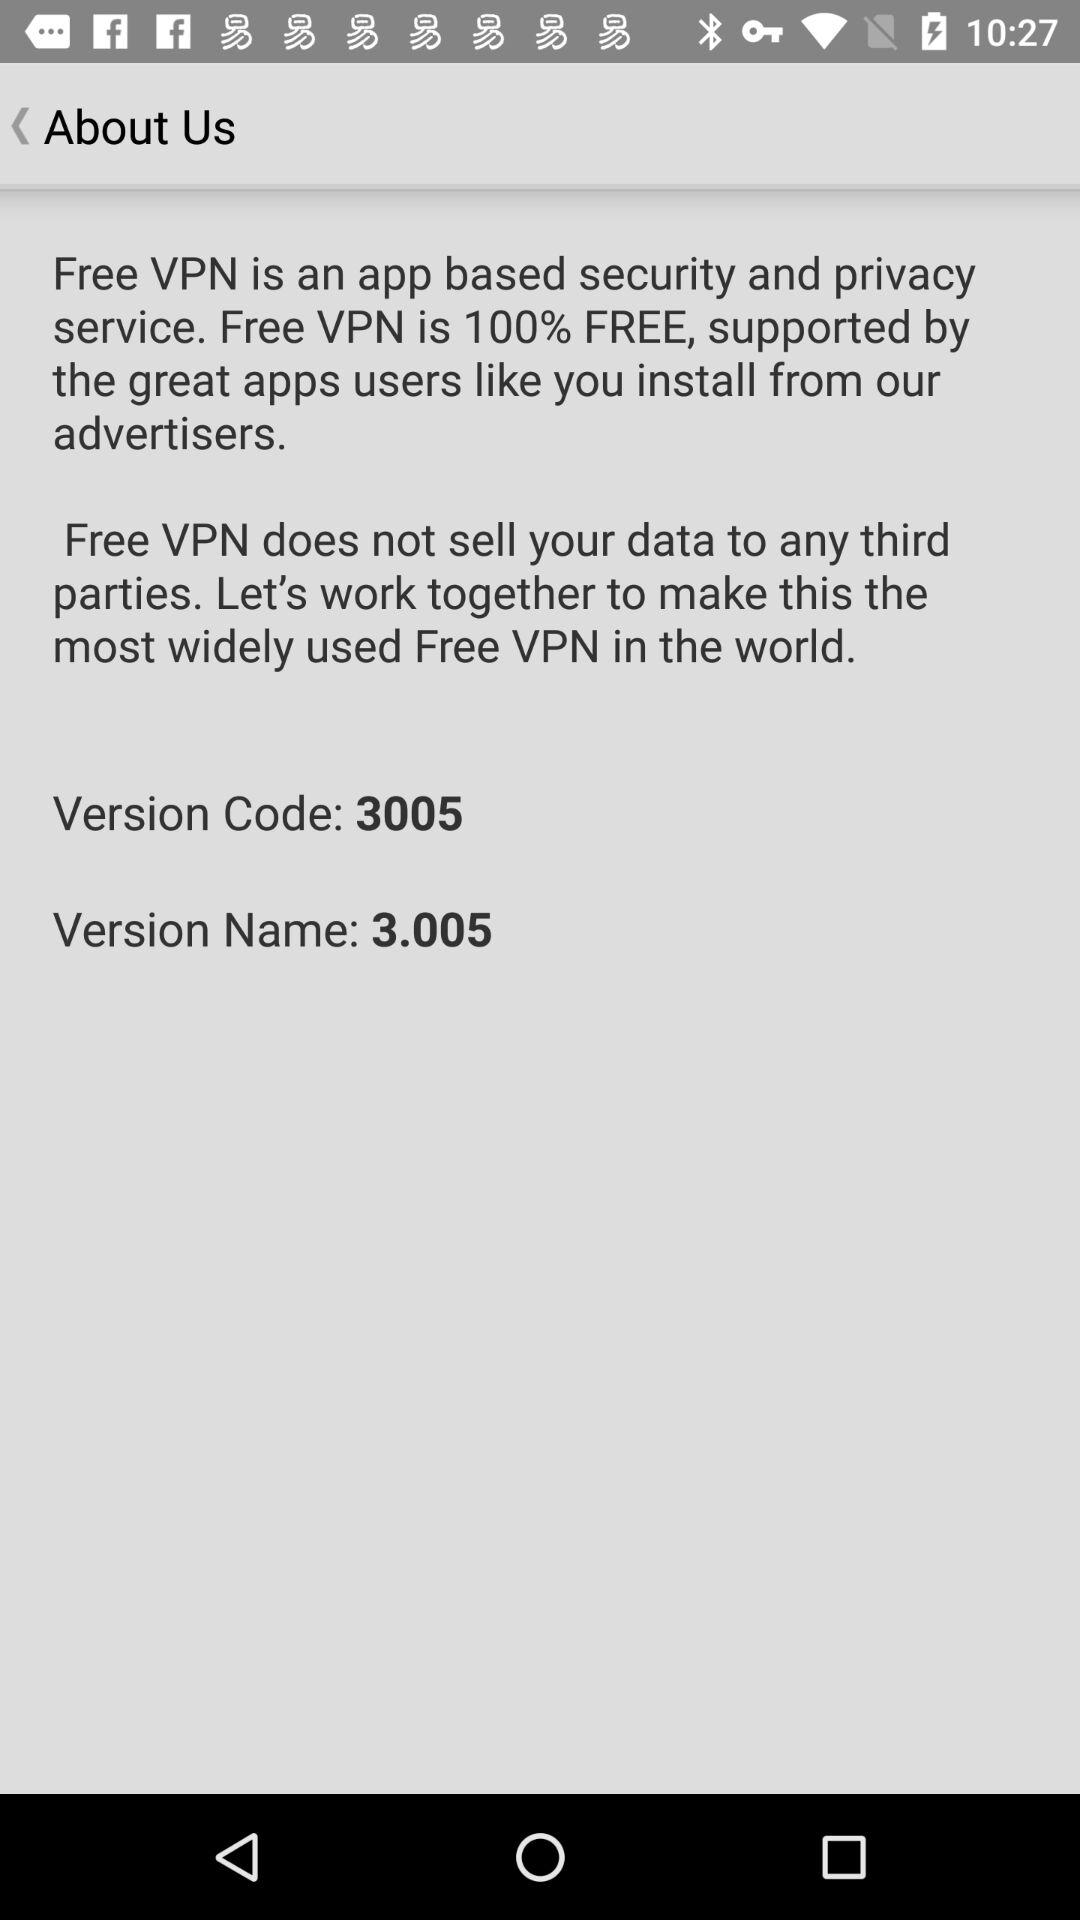Who developed the "Free VPN" app?
When the provided information is insufficient, respond with <no answer>. <no answer> 